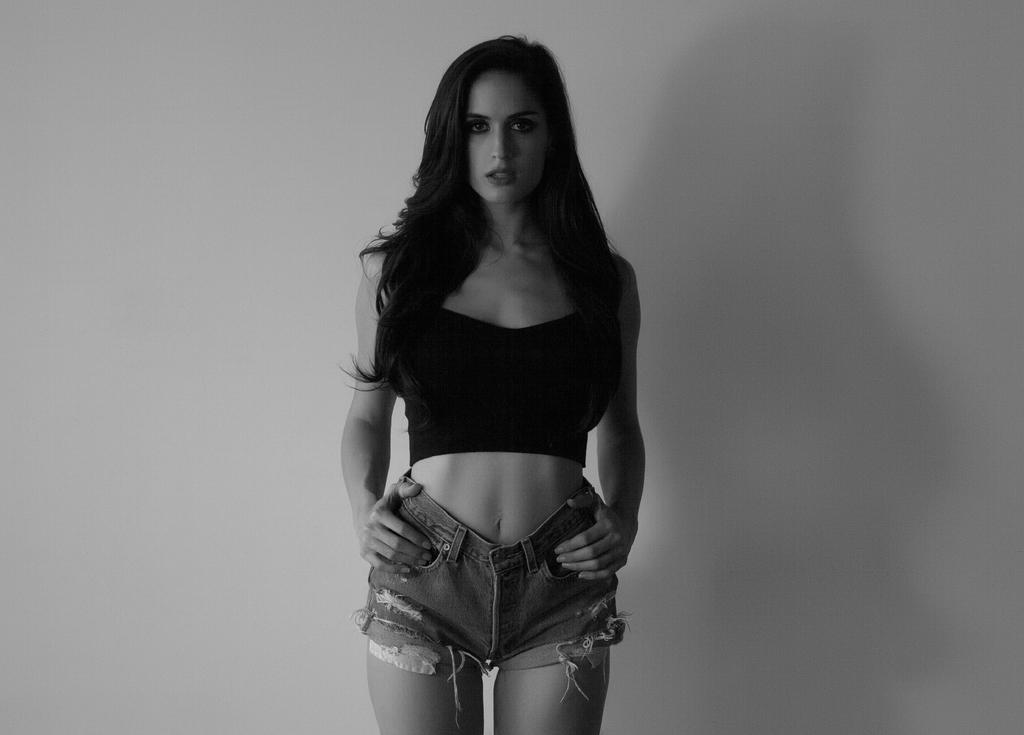Where was the picture taken? The picture was taken indoors. Who is in the image? There is a woman in the image. What is the woman wearing? The woman is wearing a black t-shirt and shorts. What is the woman's position in the image? The woman is standing on the ground. What can be seen in the background of the image? There is a wall in the background of the image. How many cows are visible on the side of the woman in the image? There are no cows visible in the image, and the woman is not shown from the side. 